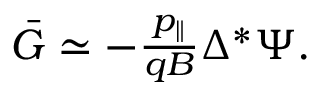Convert formula to latex. <formula><loc_0><loc_0><loc_500><loc_500>\begin{array} { r } { \bar { G } \simeq - \frac { p _ { \| } } { q B } \Delta ^ { * } \Psi . } \end{array}</formula> 